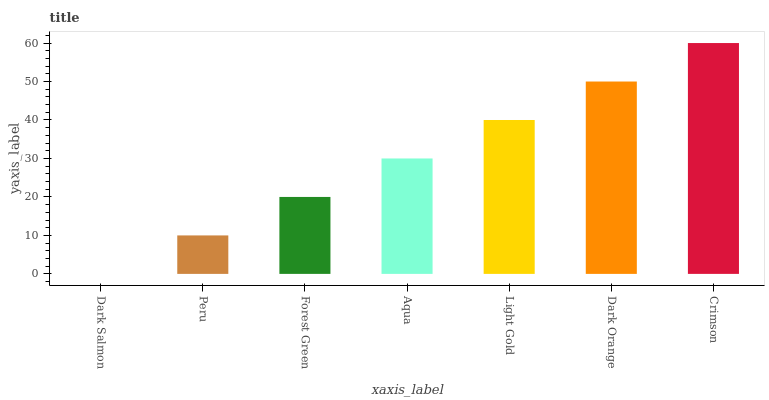Is Dark Salmon the minimum?
Answer yes or no. Yes. Is Crimson the maximum?
Answer yes or no. Yes. Is Peru the minimum?
Answer yes or no. No. Is Peru the maximum?
Answer yes or no. No. Is Peru greater than Dark Salmon?
Answer yes or no. Yes. Is Dark Salmon less than Peru?
Answer yes or no. Yes. Is Dark Salmon greater than Peru?
Answer yes or no. No. Is Peru less than Dark Salmon?
Answer yes or no. No. Is Aqua the high median?
Answer yes or no. Yes. Is Aqua the low median?
Answer yes or no. Yes. Is Peru the high median?
Answer yes or no. No. Is Crimson the low median?
Answer yes or no. No. 